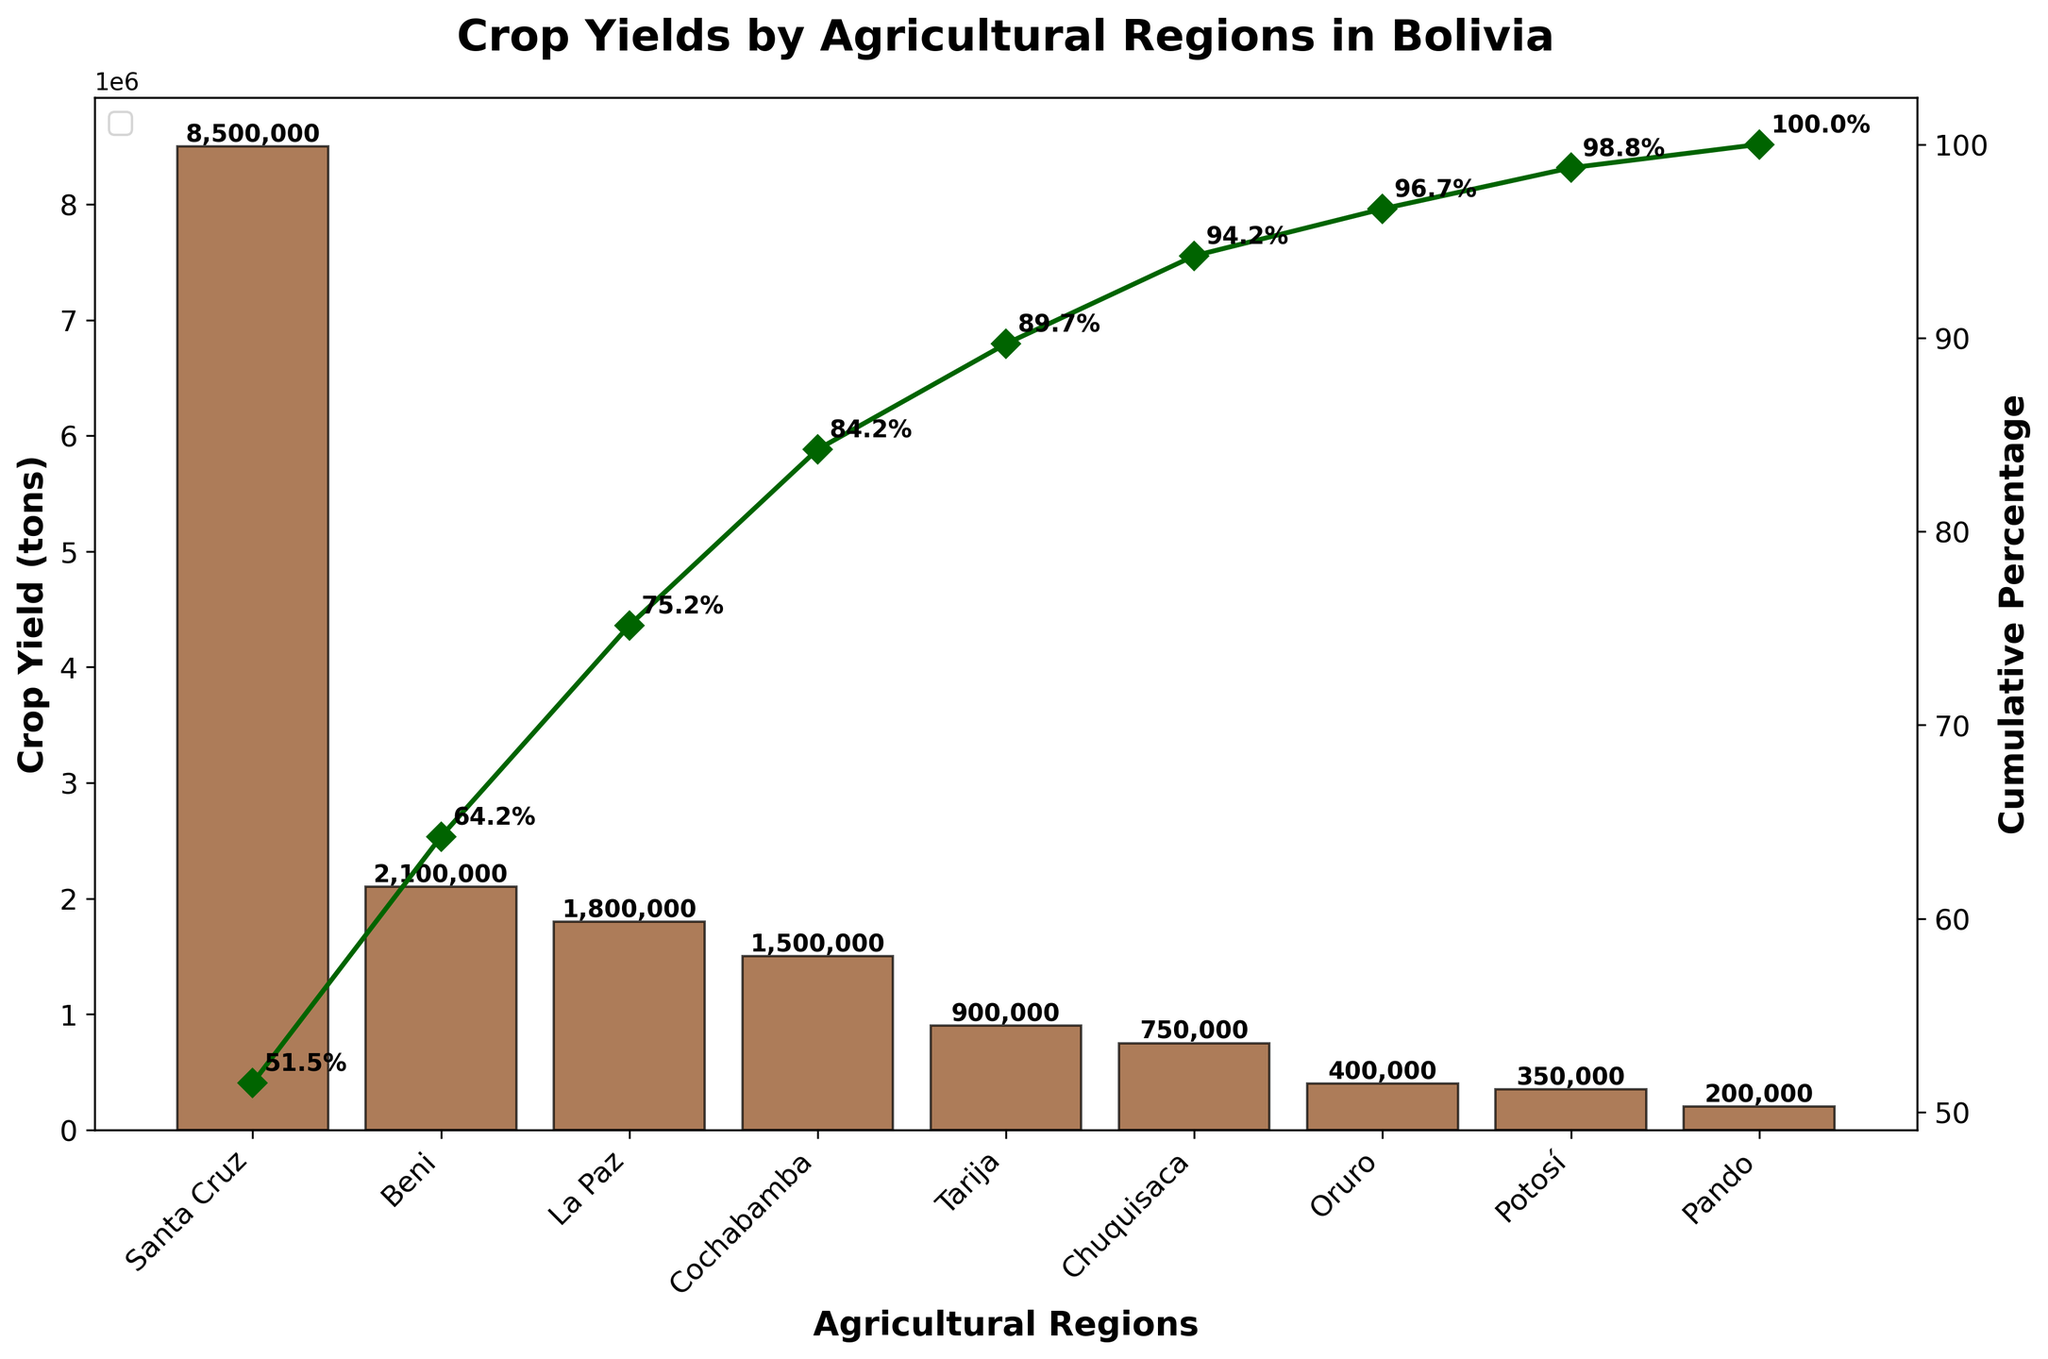What is the title of the figure? The title is prominently displayed at the top of the figure.
Answer: Crop Yields by Agricultural Regions in Bolivia Which region has the highest crop yield? By looking at the highest bar in the Pareto chart, you can see which region it represents.
Answer: Santa Cruz Which three regions have the lowest crop yields? Identify the three shortest bars at the rightmost side of the Pareto chart.
Answer: Oruro, Potosí, Pando By what percentage does Santa Cruz alone contribute to the total crop yield? Locate the bar for Santa Cruz and its yield label or calculate its height, then find its percentage representation on the cumulative percentage line.
Answer: \( \approx 58.5% \) What is the cumulative crop yield percentage up to Cochabamba? Travel along the cumulative percentage line up to the point where Cochabamba is located, and read the percentage value labeled on or near the line.
Answer: \( \approx 84.2% \) How much more crop yield does Santa Cruz have compared to Cochabamba? Subtract the crop yield of Cochabamba from Santa Cruz. E.g., 8500000 - 1500000.
Answer: 7000000 tons What is the combined yield of the regions that contribute to at least 75% of the total cumulative crop yield? Identify the regions up to and including La Paz from the cumulative percentage line, and sum their crop yields: 8500000 (Santa Cruz) + 2100000 (Beni) + 1800000 (La Paz).
Answer: 12400000 tons Which region is ranked fourth in crop yield and what percentage of the total yield does this region represent? Look to the fourth highest bar, which corresponds to the fourth sorted crop yield, and check either its yield label or cumulative percentage label.
Answer: Cochabamba, \( \approx 10.4% \) Do Beni and Tarija combined produce more crop yield than Santa Cruz? Sum the crop yields of Beni and Tarija, then compare this total to the crop yield of Santa Cruz: 2100000 (Beni) + 900000 (Tarija) versus 8500000 (Santa Cruz).
Answer: No What percentage of the total crop yield comes from regions with yields less than 1,000,000 tons? Sum the yields of the regions with yields under 1,000,000 tons (Tarija, Chuquisaca, Oruro, Potosí, Pando) and divide by the total yield, then multiply by 100 to get the percentage: (900000 + 750000 + 400000 + 350000 + 200000) / (8500000 + 2100000 + 1800000 + 1500000 + 900000 + 750000 + 400000 + 350000 + 200000) * 100.
Answer: \( \approx 8.3% \) 